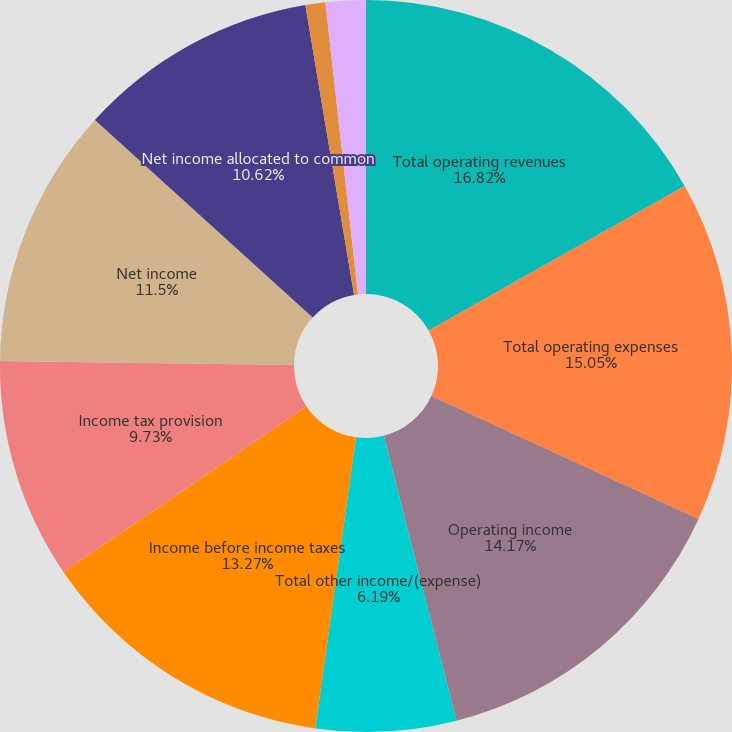Convert chart. <chart><loc_0><loc_0><loc_500><loc_500><pie_chart><fcel>Total operating revenues<fcel>Total operating expenses<fcel>Operating income<fcel>Total other income/(expense)<fcel>Income before income taxes<fcel>Income tax provision<fcel>Net income<fcel>Net income allocated to common<fcel>Basic<fcel>Diluted<nl><fcel>16.81%<fcel>15.04%<fcel>14.16%<fcel>6.19%<fcel>13.27%<fcel>9.73%<fcel>11.5%<fcel>10.62%<fcel>0.88%<fcel>1.77%<nl></chart> 